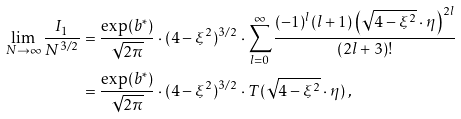Convert formula to latex. <formula><loc_0><loc_0><loc_500><loc_500>\lim _ { N \to \infty } \frac { I _ { 1 } } { N ^ { 3 / 2 } } & = \frac { \exp ( b ^ { * } ) } { \sqrt { 2 \pi } } \cdot ( 4 - \xi ^ { 2 } ) ^ { 3 / 2 } \cdot \sum _ { l = 0 } ^ { \infty } \frac { ( - 1 ) ^ { l } ( l + 1 ) \left ( \sqrt { 4 - \xi ^ { 2 } } \cdot \eta \right ) ^ { 2 l } } { ( 2 l + 3 ) ! } \\ & = \frac { \exp ( b ^ { * } ) } { \sqrt { 2 \pi } } \cdot ( 4 - \xi ^ { 2 } ) ^ { 3 / 2 } \cdot T ( \sqrt { 4 - \xi ^ { 2 } } \cdot \eta ) \, ,</formula> 